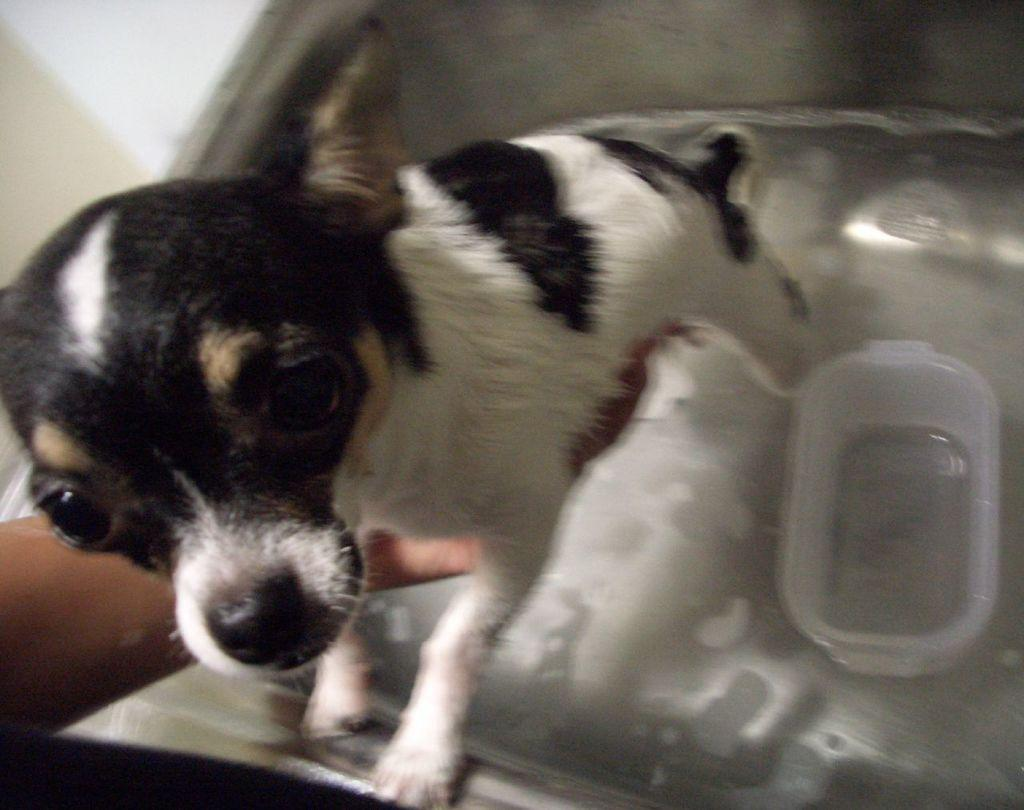What type of animal is present in the image? There is a dog in the image. What is the dog interacting with in the image? The dog is interacting with a box in the water in the image. Can you describe the position of the person's hand in the image? There is a person's hand on the left side of the image. What country is depicted in the image? There is no country depicted in the image; it features a dog, a box in the water, and a person's hand. In what year was the image taken? The year the image was taken is not mentioned in the provided facts. 